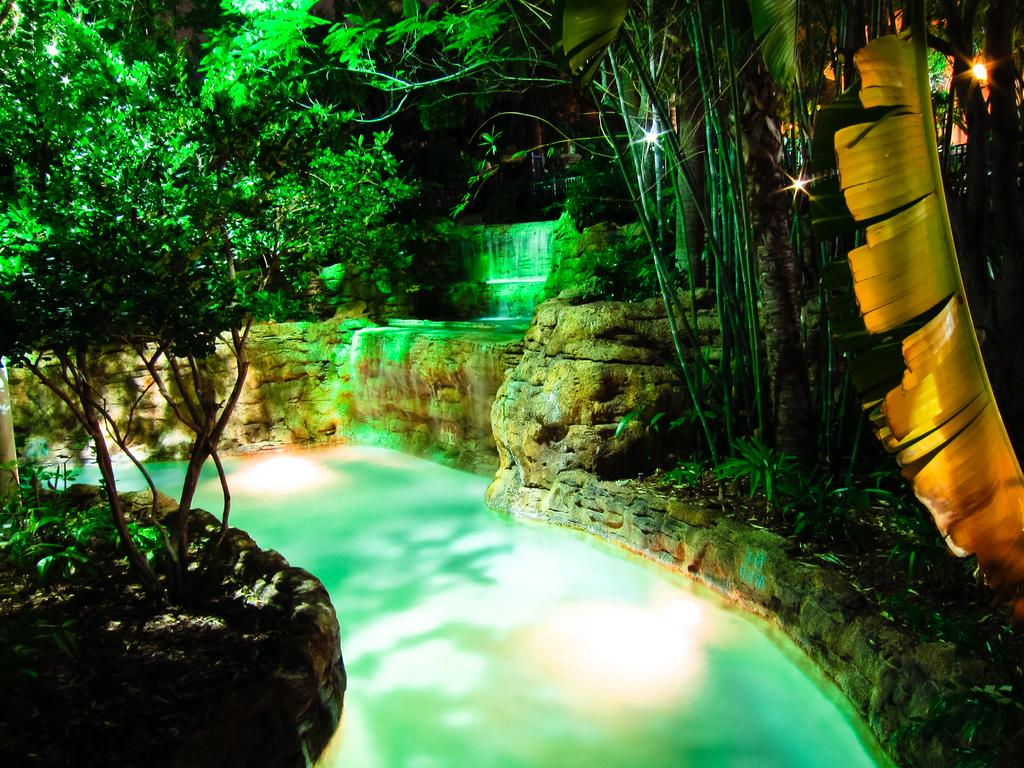What type of vegetation is present in the image? There are trees with branches and leaves in the image. What body of water can be seen in the image? There is a pool with water in the image. What type of natural formation is visible in the image? There are rocks in the image. What type of territory is being claimed by the flesh in the image? There is no mention of territory or flesh in the image; it features trees, a pool, and rocks. 